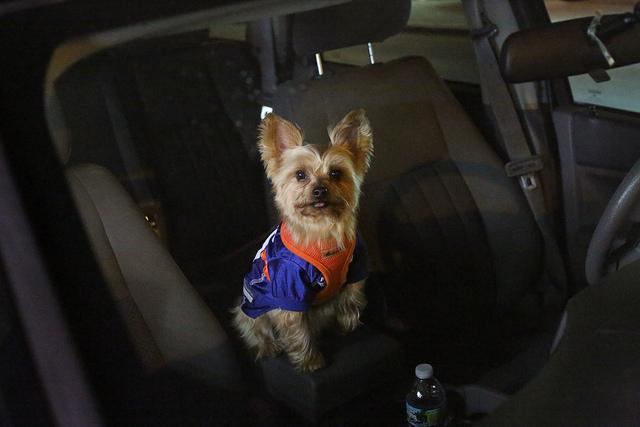What beverage is visible?
Short answer required. Water. What is blonde and white colored?
Answer briefly. Dog. What kind of dog is this?
Write a very short answer. Yorkie. Is the dog inside of the car?
Answer briefly. Yes. What is the dog wearing?
Be succinct. Shirt. 